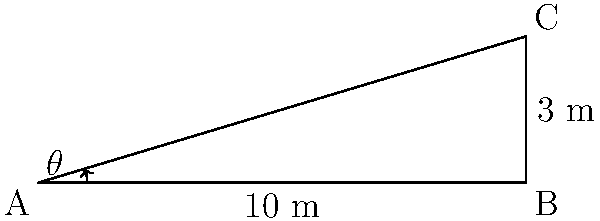An animal nutritionist is designing an inclined exercise platform for pets to promote joint health. The platform is 10 meters long and needs to be elevated 3 meters at one end. What is the optimal angle $\theta$ (in degrees) for the incline to ensure effective joint exercise without causing strain? To find the angle $\theta$, we can use the trigonometric function tangent (tan). In a right triangle:

1) $\tan(\theta) = \frac{\text{opposite}}{\text{adjacent}}$

2) In this case:
   - Opposite side (elevation) = 3 meters
   - Adjacent side (base length) = 10 meters

3) Therefore:
   $\tan(\theta) = \frac{3}{10} = 0.3$

4) To find $\theta$, we need to use the inverse tangent function (arctan or $\tan^{-1}$):
   $\theta = \tan^{-1}(0.3)$

5) Using a calculator or trigonometric tables:
   $\theta \approx 16.70^\circ$

6) Rounding to the nearest tenth of a degree:
   $\theta \approx 16.7^\circ$

This angle provides a gentle incline that promotes joint movement without putting excessive stress on the pet's joints.
Answer: $16.7^\circ$ 